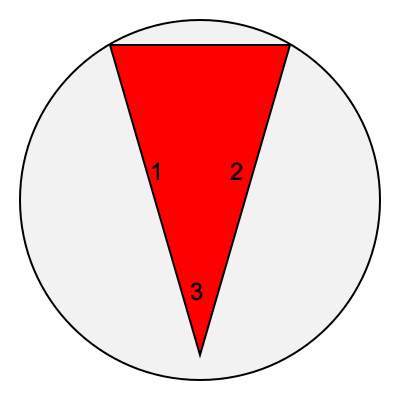As a devoted fan of the Filipino television industry, you're familiar with the iconic ABS-CBN logo. The image shows three rotations of a simplified version of this logo. Which rotation correctly represents the standard orientation of the ABS-CBN logo as seen on television? To answer this question, we need to analyze the rotations of the simplified ABS-CBN logo and compare them to the standard orientation seen on television:

1. The ABS-CBN logo is typically displayed as an upright triangle with three colored bands.
2. In the standard orientation, the triangle points upward, with the red band at the top.
3. Examining the three rotations in the image:
   - Rotation 1 (left): The triangle points to the left, which is incorrect.
   - Rotation 2 (right): The triangle points to the right, which is also incorrect.
   - Rotation 3 (bottom): The triangle points upward, matching the standard orientation.
4. The upward-pointing triangle in rotation 3 correctly represents how the logo appears on television, with the widest part of the triangle at the top and the point at the bottom.

Therefore, rotation 3 is the correct representation of the standard ABS-CBN logo orientation.
Answer: 3 